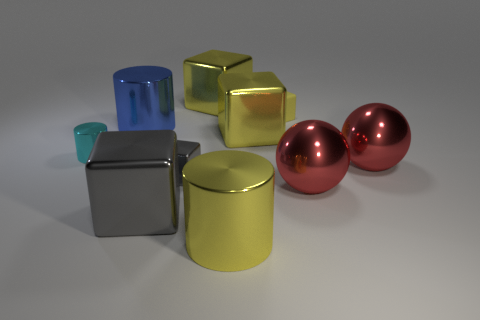Do the tiny matte block and the tiny metal cylinder have the same color?
Your answer should be very brief. No. What number of big shiny things are the same color as the tiny metal block?
Ensure brevity in your answer.  1. There is a big metal cylinder that is on the right side of the tiny gray shiny block; is its color the same as the rubber thing?
Provide a succinct answer. Yes. What shape is the shiny object that is behind the big blue metallic cylinder?
Provide a succinct answer. Cube. There is a yellow object that is behind the tiny rubber cube; are there any yellow metal blocks behind it?
Offer a terse response. No. What number of big yellow blocks are the same material as the tiny cyan cylinder?
Your response must be concise. 2. There is a red shiny thing behind the red ball that is in front of the tiny object that is in front of the cyan object; what size is it?
Offer a terse response. Large. How many big blue cylinders are in front of the big blue cylinder?
Ensure brevity in your answer.  0. Are there more tiny brown metallic blocks than things?
Keep it short and to the point. No. The cylinder that is the same color as the matte cube is what size?
Provide a short and direct response. Large. 